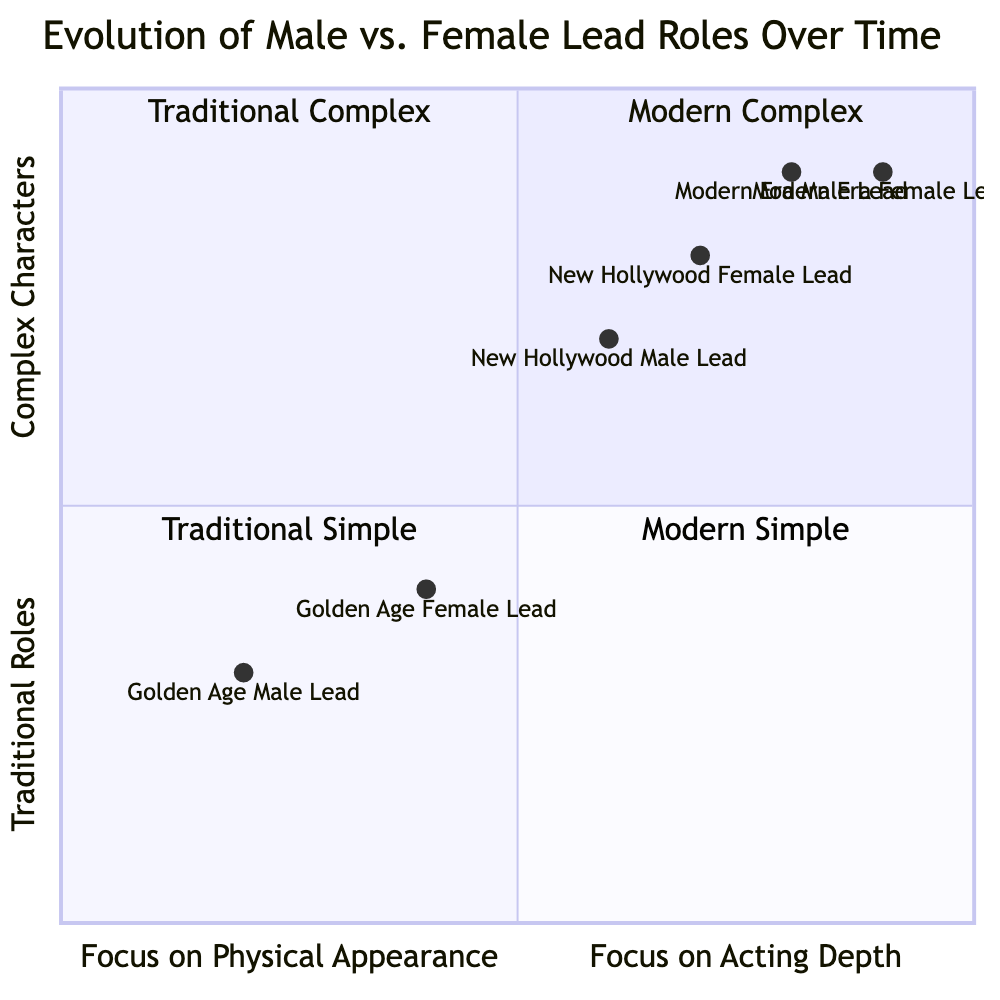What quadrant does the Golden Age male lead occupy? The Golden Age male lead has coordinates [0.2, 0.3], which places it in the quadrant labeled "Traditional Simple" since it falls in the lower-left area of the chart.
Answer: Traditional Simple Which era has the highest focus on physical appearance for male leads? The Modern Era male lead has coordinates [0.8, 0.9], which is the highest value on the x-axis in the diagram, indicating the greatest focus on physical appearance.
Answer: Modern Era How many female lead roles are categorized as "Complex Characters"? The New Hollywood female lead with coordinates [0.7, 0.8] and the Modern Era female lead with coordinates [0.9, 0.9] both fall into the quadrant labeled "Modern Complex," which includes complex characters. Thus, there are two female lead roles categorized this way.
Answer: 2 Which era's female lead is the most traditional? The Golden Age female lead, with coordinates [0.4, 0.4], is closest to the quadrant labeled "Traditional Simple," making her the most traditional in the diagram.
Answer: Golden Age Identify the predominant genres for male leads in the Modern Era. The dominant genres for male leads in the Modern Era include Action and Drama as indicated in the description of the roles, reflecting their character attributes of being multi-dimensional and vulnerable.
Answer: Action, Drama 